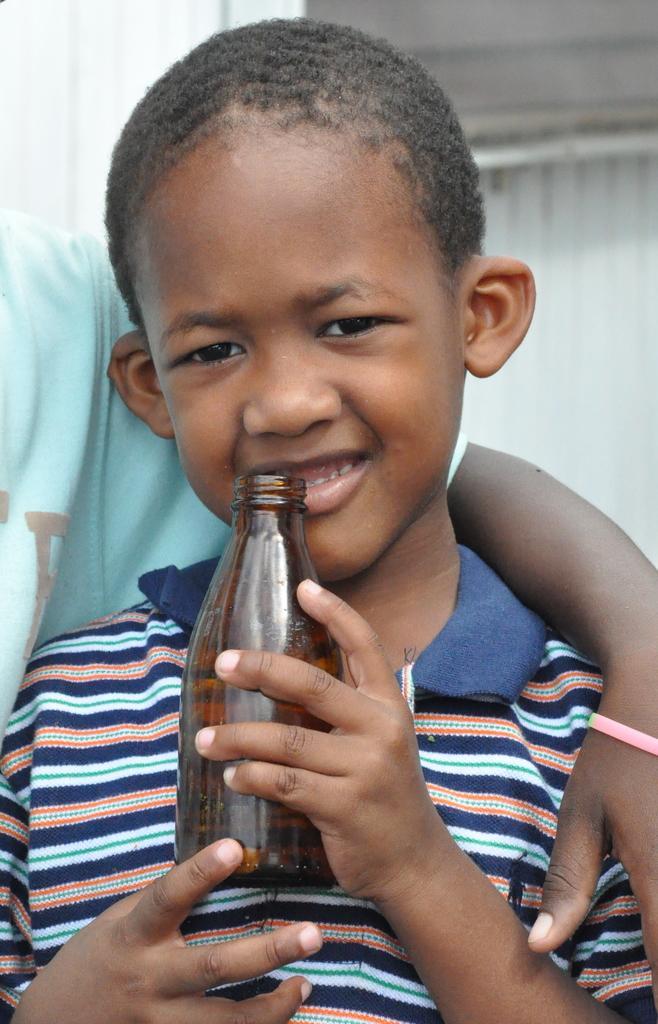Can you describe this image briefly? This kid is highlighted in this picture. This kid is holding a bottle. Beside this kid another person is standing and this person kept his hand on this kid shoulder. 